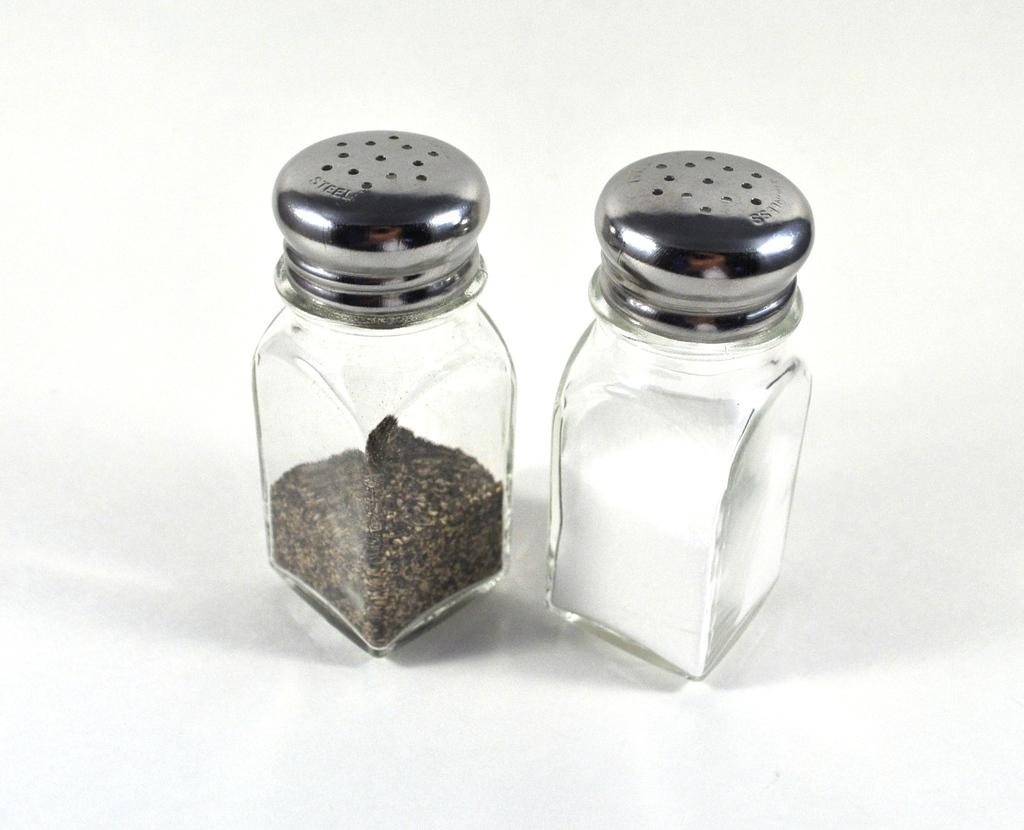How many jars are visible in the image? There are two jars in the image. What is inside the jars? The jars contain powders. What color is the surface beneath the jars? The surface beneath the jars is white. How many worms can be seen crawling on the surface beneath the jars? There are no worms present in the image; the surface beneath the jars is white. 